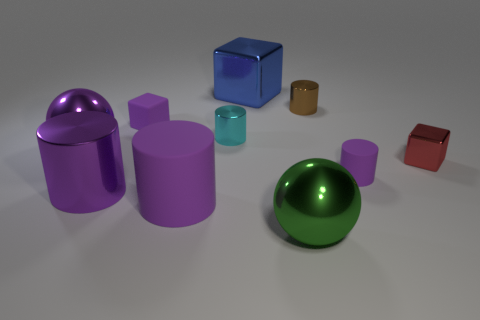Is the big ball behind the green thing made of the same material as the big purple object to the right of the purple shiny cylinder?
Offer a very short reply. No. There is a small cylinder that is the same color as the big rubber object; what is its material?
Make the answer very short. Rubber. What material is the small thing that is on the right side of the small brown cylinder and on the left side of the red thing?
Offer a terse response. Rubber. Does the large blue object have the same material as the purple object that is to the right of the big green shiny thing?
Keep it short and to the point. No. How many things are either big purple metallic objects or tiny metal things in front of the small brown cylinder?
Your answer should be compact. 4. Does the metal ball in front of the small purple cylinder have the same size as the block in front of the rubber block?
Make the answer very short. No. What number of other objects are the same color as the big rubber cylinder?
Provide a short and direct response. 4. There is a green thing; is it the same size as the metal cylinder that is in front of the red block?
Offer a terse response. Yes. What is the size of the rubber cylinder that is to the right of the large purple cylinder on the right side of the small matte cube?
Ensure brevity in your answer.  Small. There is a tiny metal object that is the same shape as the big blue thing; what color is it?
Provide a succinct answer. Red. 